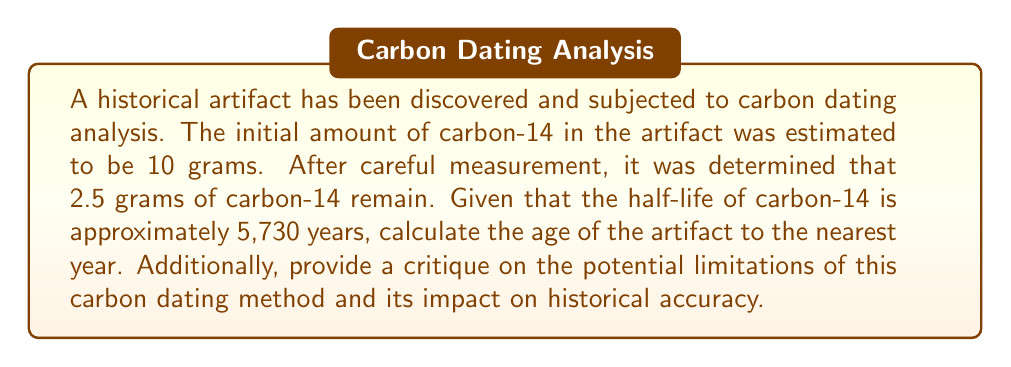Help me with this question. To solve this problem and address the concerns of a critical historical biographer, we'll follow these steps:

1) The exponential decay function for radioactive isotopes is:

   $$A(t) = A_0 \cdot e^{-\lambda t}$$

   Where:
   $A(t)$ is the amount remaining after time $t$
   $A_0$ is the initial amount
   $\lambda$ is the decay constant
   $t$ is the time elapsed

2) We need to find $\lambda$ using the half-life:

   $$T_{1/2} = \frac{\ln(2)}{\lambda}$$
   $$\lambda = \frac{\ln(2)}{T_{1/2}} = \frac{\ln(2)}{5730} \approx 0.000121$$

3) Now we can set up our equation:

   $$2.5 = 10 \cdot e^{-0.000121t}$$

4) Solve for $t$:

   $$\frac{2.5}{10} = e^{-0.000121t}$$
   $$\ln(0.25) = -0.000121t$$
   $$t = \frac{\ln(0.25)}{-0.000121} \approx 11460.9$$

5) Rounding to the nearest year:

   $t \approx 11,461$ years

Critique on limitations:

a) Assumption of constant decay rate: This method assumes that the rate of carbon-14 decay has remained constant over time, which may not be entirely accurate due to variations in cosmic ray intensity and Earth's magnetic field.

b) Initial carbon-14 content: The method assumes knowledge of the initial carbon-14 content, which can vary depending on atmospheric conditions and the specific organism.

c) Contamination: The sample may be contaminated with newer or older carbon, leading to inaccurate results.

d) Limited range: Carbon dating is only reliable for objects up to about 50,000 years old, limiting its application for older artifacts.

e) Calibration issues: The need for calibration against other dating methods introduces additional uncertainties.

f) Sample size: Small sample sizes can lead to larger margins of error.

These limitations underscore the importance of cross-referencing with other dating methods and historical context for a more accurate historical narrative.
Answer: 11,461 years 